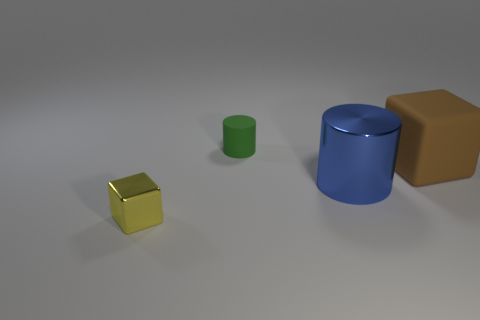Are there any tiny red blocks made of the same material as the large brown object?
Your response must be concise. No. How many metallic things are either large things or blue things?
Your answer should be compact. 1. There is a matte object that is in front of the small object behind the tiny yellow object; what shape is it?
Ensure brevity in your answer.  Cube. Is the number of small yellow blocks right of the small cylinder less than the number of purple cylinders?
Your answer should be compact. No. What is the shape of the green matte thing?
Offer a very short reply. Cylinder. What is the size of the shiny object that is in front of the metallic cylinder?
Your response must be concise. Small. There is a cube that is the same size as the green thing; what color is it?
Make the answer very short. Yellow. Is there another big object of the same color as the large shiny thing?
Your answer should be compact. No. Are there fewer large cylinders in front of the big cylinder than metal things to the right of the tiny green rubber thing?
Keep it short and to the point. Yes. There is a thing that is both behind the blue metallic cylinder and right of the green rubber cylinder; what is it made of?
Make the answer very short. Rubber. 